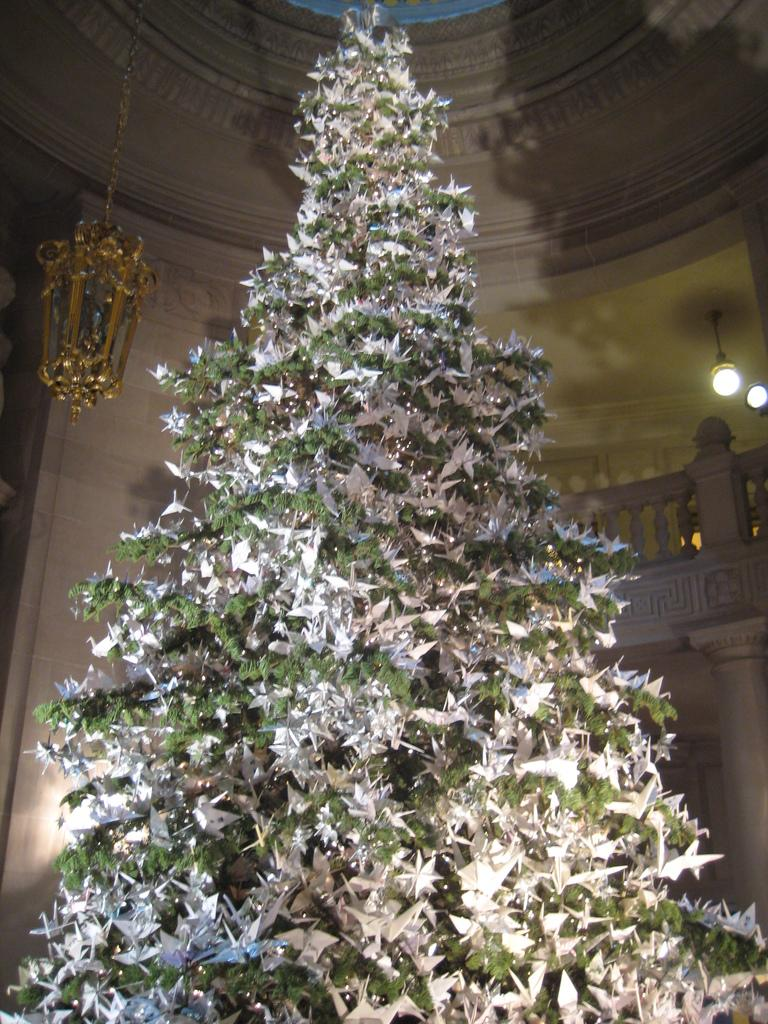What is the main subject in the center of the image? There is a Christmas tree in the center of the image. What can be seen in the background of the image? There is a wall, lights, a pillar, and another wall in the background of the image. Can you describe the wall in the background? There is a wall in the background of the image, but no specific details about its appearance are provided. How many toes can be seen on the island in the image? There is no island or toes present in the image. 